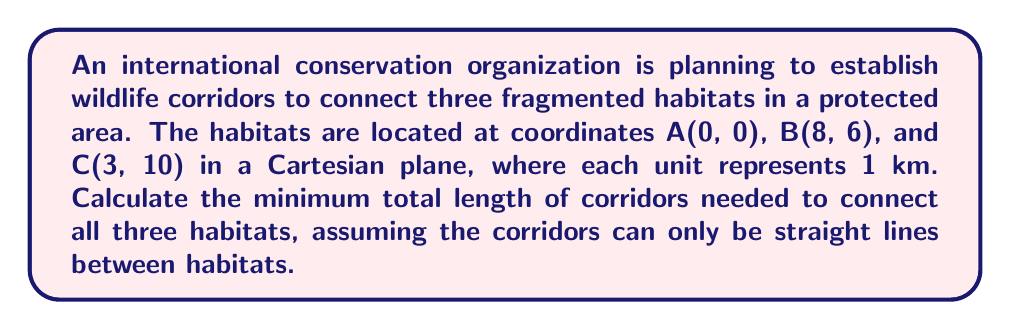Solve this math problem. To solve this problem, we need to use the concept of the Steiner tree in topology, which finds the shortest network connecting a given set of points. In this case, we're dealing with the simplest form of a Steiner tree problem, known as the Fermat point problem for three points.

Step 1: Calculate the distances between each pair of habitats using the distance formula:
$$d = \sqrt{(x_2-x_1)^2 + (y_2-y_1)^2}$$

AB = $\sqrt{(8-0)^2 + (6-0)^2} = \sqrt{64 + 36} = \sqrt{100} = 10$ km
BC = $\sqrt{(3-8)^2 + (10-6)^2} = \sqrt{25 + 16} = \sqrt{41} \approx 6.40$ km
AC = $\sqrt{(3-0)^2 + (10-0)^2} = \sqrt{9 + 100} = \sqrt{109} \approx 10.44$ km

Step 2: Check if any angle in the triangle ABC is greater than or equal to 120°. If so, the shortest network is simply the two shorter sides of the triangle.

To find the angles, we can use the law of cosines:
$$\cos \theta = \frac{a^2 + b^2 - c^2}{2ab}$$

Angle at A: $\cos A = \frac{10^2 + 10.44^2 - 6.40^2}{2(10)(10.44)} \approx 0.8660$
$A \approx \arccos(0.8660) \approx 30°$

Angle at B: $\cos B = \frac{10^2 + 6.40^2 - 10.44^2}{2(10)(6.40)} \approx 0.5000$
$B \approx \arccos(0.5000) \approx 60°$

Angle at C: $\cos C = \frac{10.44^2 + 6.40^2 - 10^2}{2(10.44)(6.40)} \approx 0.5000$
$C \approx \arccos(0.5000) \approx 60°$

Since no angle is greater than or equal to 120°, we need to find the Fermat point.

Step 3: The Fermat point is the point where all three angles are equal to 120°. The minimum total length of corridors is the sum of the distances from this point to each habitat.

For an equilateral triangle, the ratio of the minimum Steiner tree length to the sum of the triangle's sides is:
$$\frac{\sqrt{3}}{2} \approx 0.866$$

The sum of the triangle's sides is: 10 + 6.40 + 10.44 = 26.84 km

Therefore, the minimum total length of corridors is:
$$26.84 \times 0.866 \approx 23.24$$ km
Answer: The minimum total length of wildlife corridors needed to connect all three habitats is approximately 23.24 km. 